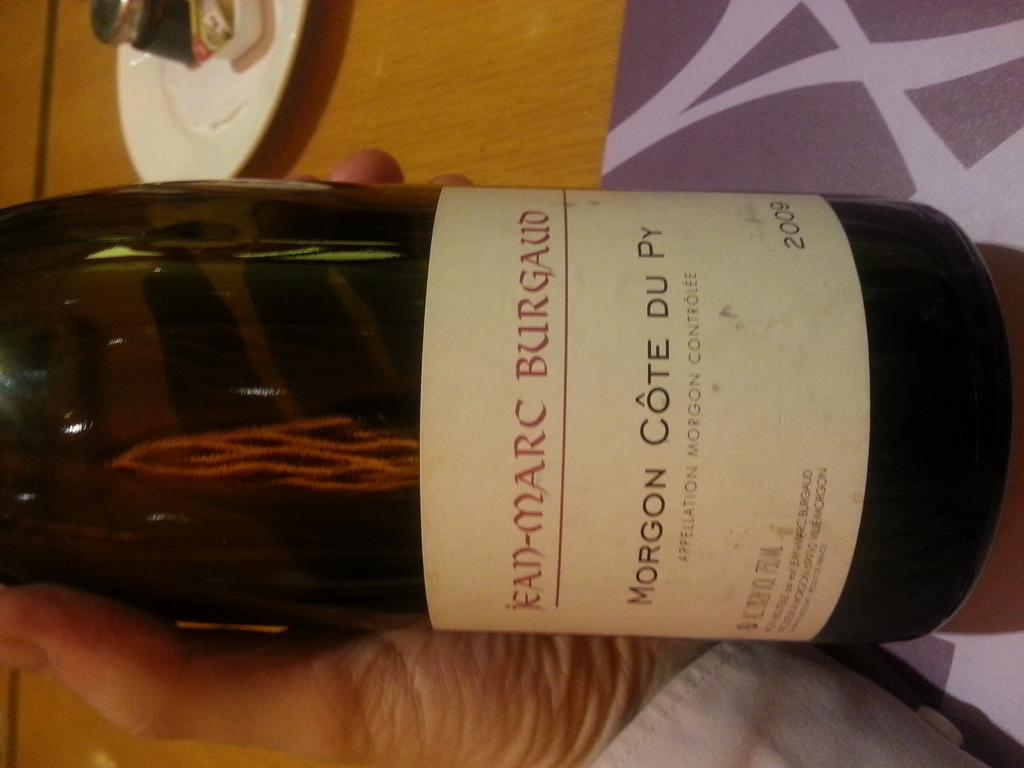<image>
Write a terse but informative summary of the picture. A bottle of Morgan Cote Du Py sits on a purple surface 